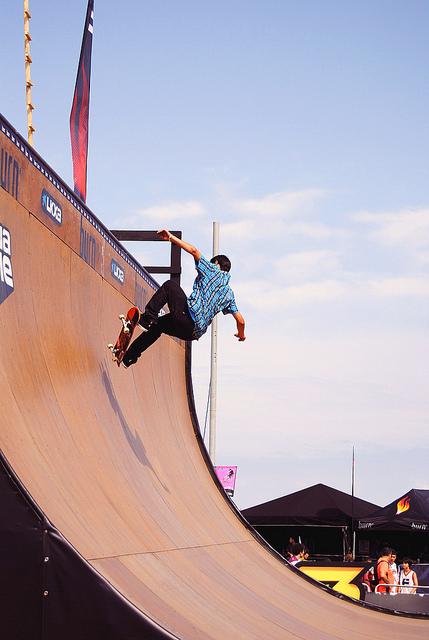What color is the ramp?
Give a very brief answer. Brown. Is this a cloudy day?
Short answer required. No. What sport is he doing?
Quick response, please. Skateboarding. 